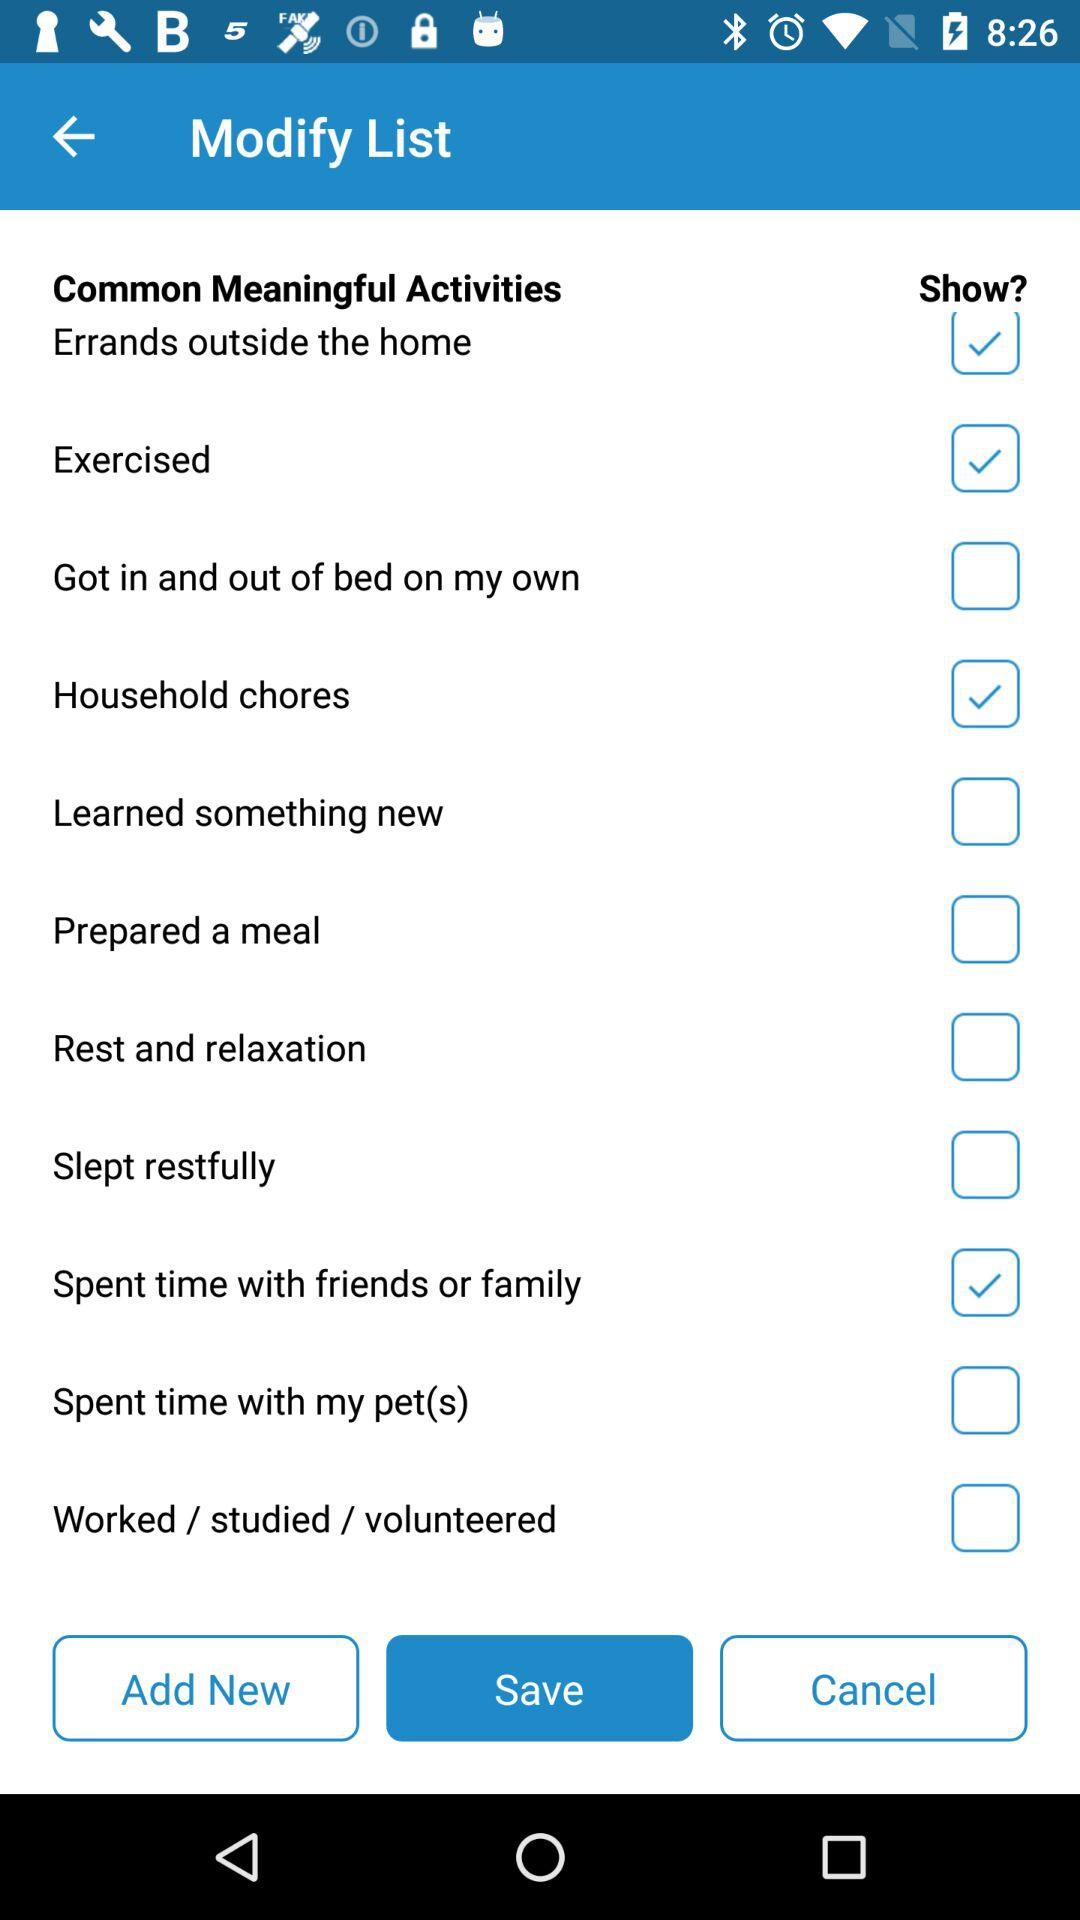Which activities are selected? The selected activities are "Errands outside the home", "Exercised", "Household chores" and "Spent time with friends or family". 